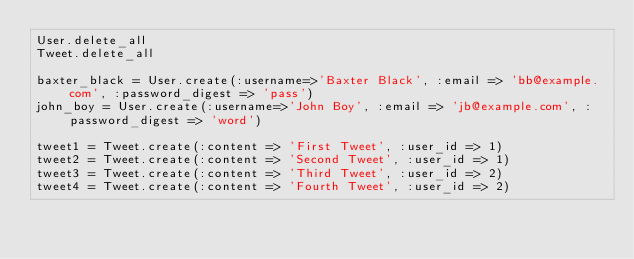Convert code to text. <code><loc_0><loc_0><loc_500><loc_500><_Ruby_>User.delete_all
Tweet.delete_all

baxter_black = User.create(:username=>'Baxter Black', :email => 'bb@example.com', :password_digest => 'pass')
john_boy = User.create(:username=>'John Boy', :email => 'jb@example.com', :password_digest => 'word')

tweet1 = Tweet.create(:content => 'First Tweet', :user_id => 1)
tweet2 = Tweet.create(:content => 'Second Tweet', :user_id => 1)
tweet3 = Tweet.create(:content => 'Third Tweet', :user_id => 2)
tweet4 = Tweet.create(:content => 'Fourth Tweet', :user_id => 2)
</code> 